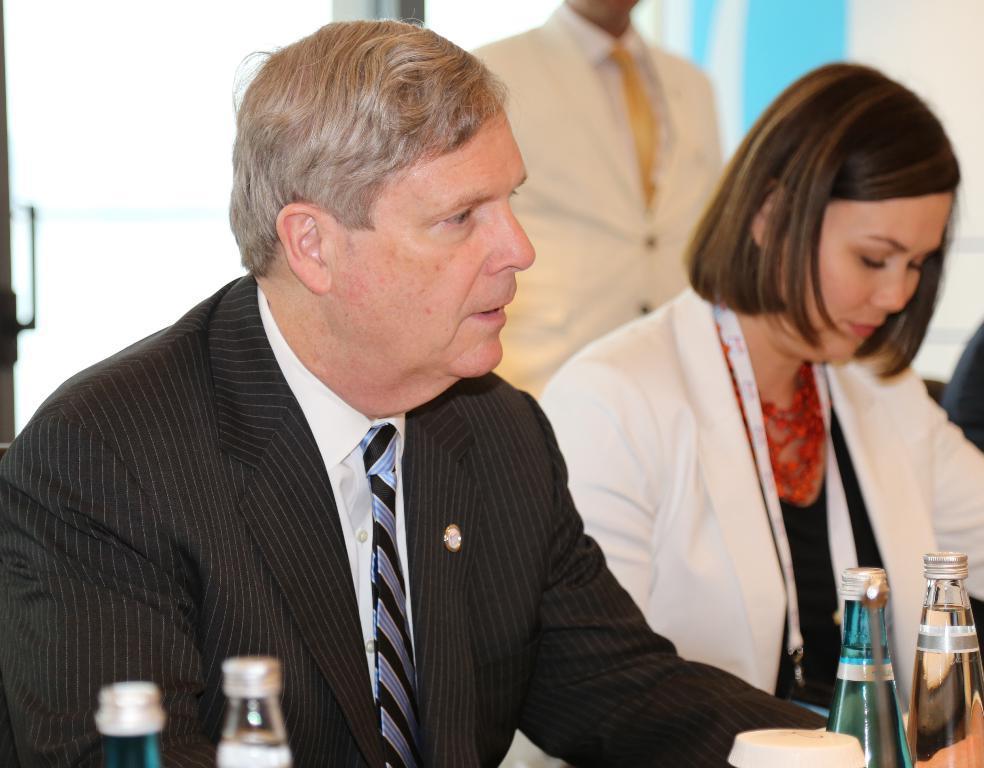How would you summarize this image in a sentence or two? This picture shows two people seated on the chairs and we see few water bottles on the table and we see a man standing on the back 